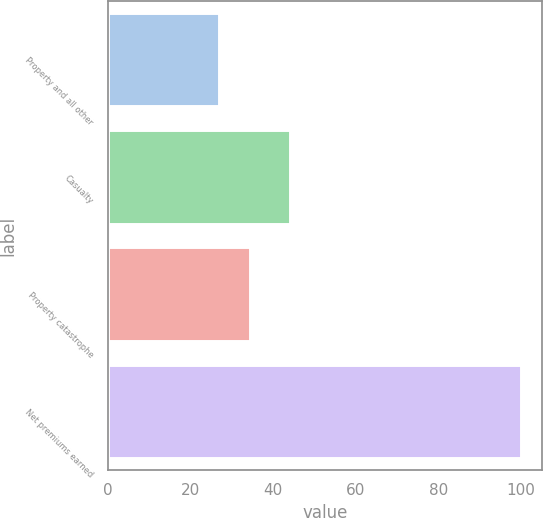Convert chart to OTSL. <chart><loc_0><loc_0><loc_500><loc_500><bar_chart><fcel>Property and all other<fcel>Casualty<fcel>Property catastrophe<fcel>Net premiums earned<nl><fcel>27<fcel>44<fcel>34.3<fcel>100<nl></chart> 